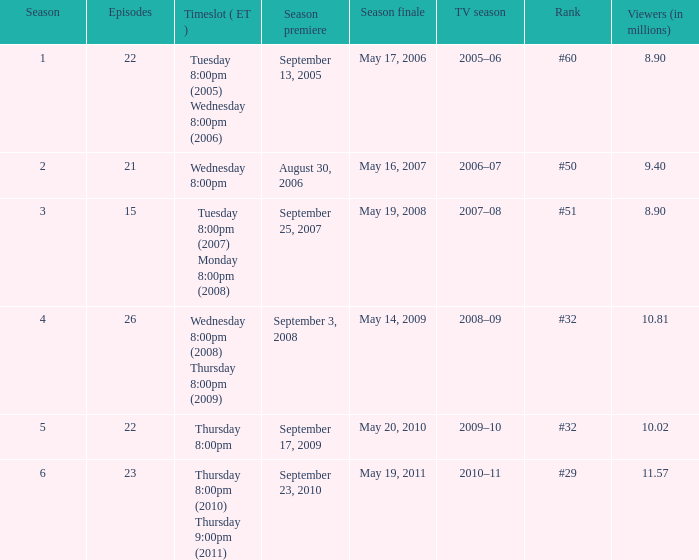What tv season was episode 23 broadcast? 2010–11. 